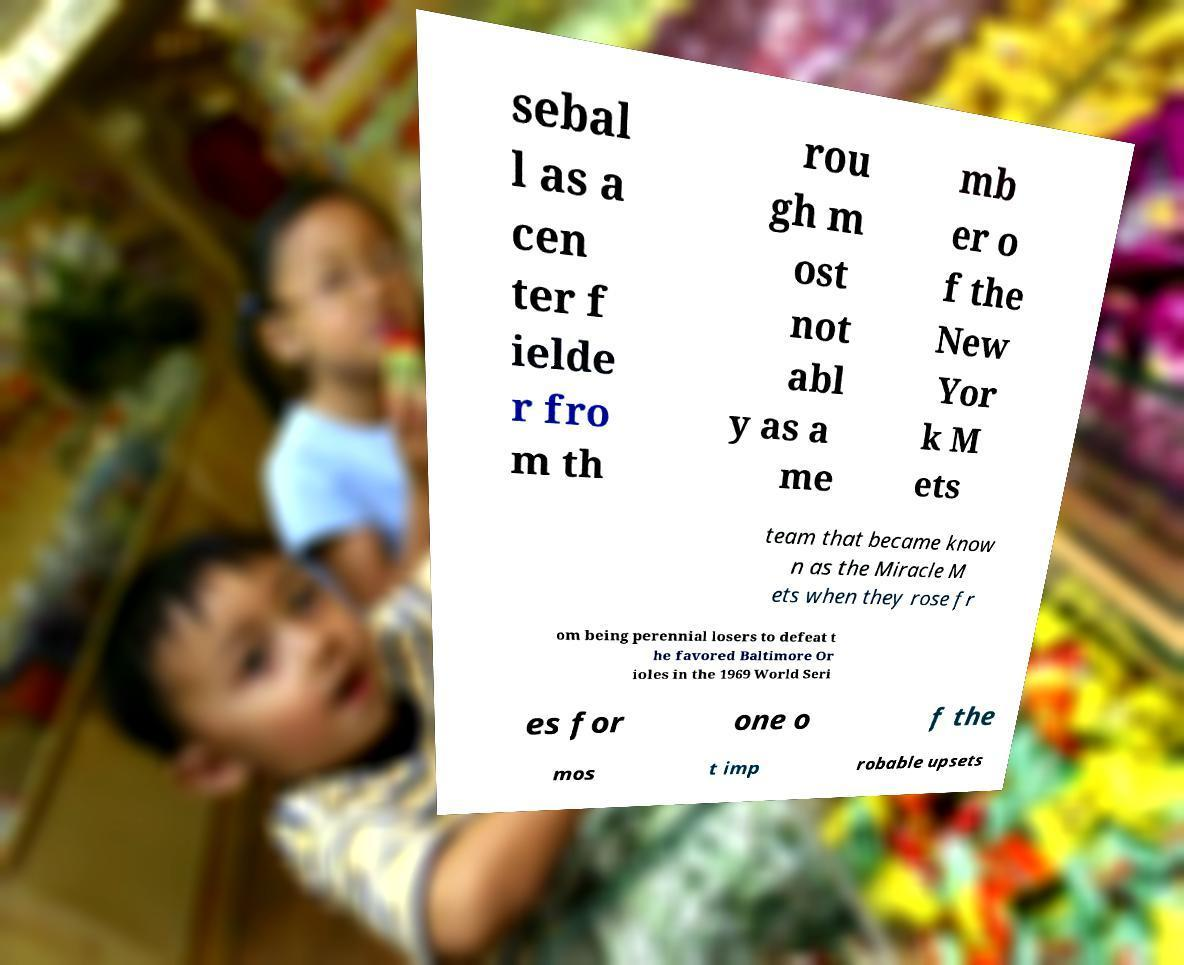What messages or text are displayed in this image? I need them in a readable, typed format. sebal l as a cen ter f ielde r fro m th rou gh m ost not abl y as a me mb er o f the New Yor k M ets team that became know n as the Miracle M ets when they rose fr om being perennial losers to defeat t he favored Baltimore Or ioles in the 1969 World Seri es for one o f the mos t imp robable upsets 